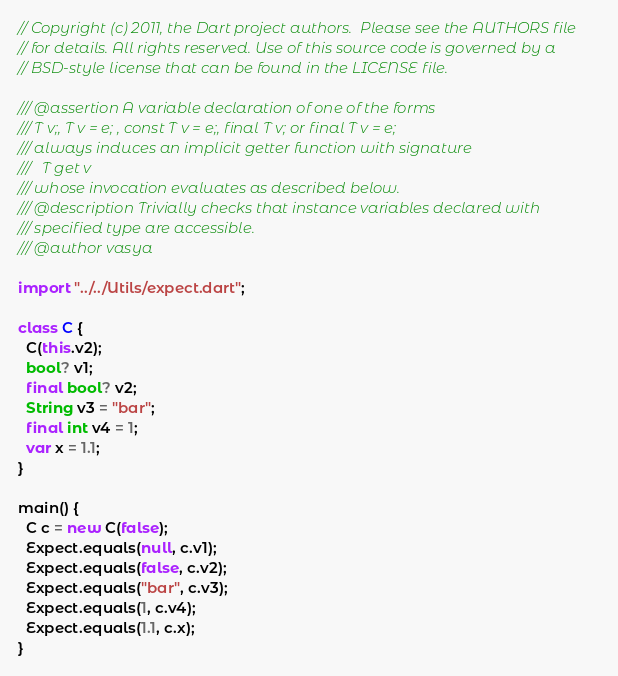Convert code to text. <code><loc_0><loc_0><loc_500><loc_500><_Dart_>// Copyright (c) 2011, the Dart project authors.  Please see the AUTHORS file
// for details. All rights reserved. Use of this source code is governed by a
// BSD-style license that can be found in the LICENSE file.

/// @assertion A variable declaration of one of the forms
/// T v;, T v = e; , const T v = e;, final T v; or final T v = e;
/// always induces an implicit getter function with signature
///   T get v
/// whose invocation evaluates as described below.
/// @description Trivially checks that instance variables declared with 
/// specified type are accessible.
/// @author vasya

import "../../Utils/expect.dart";

class C {
  C(this.v2);
  bool? v1;
  final bool? v2;
  String v3 = "bar";
  final int v4 = 1;
  var x = 1.1;
}

main() {
  C c = new C(false);
  Expect.equals(null, c.v1);
  Expect.equals(false, c.v2);
  Expect.equals("bar", c.v3);
  Expect.equals(1, c.v4);
  Expect.equals(1.1, c.x);
}
</code> 